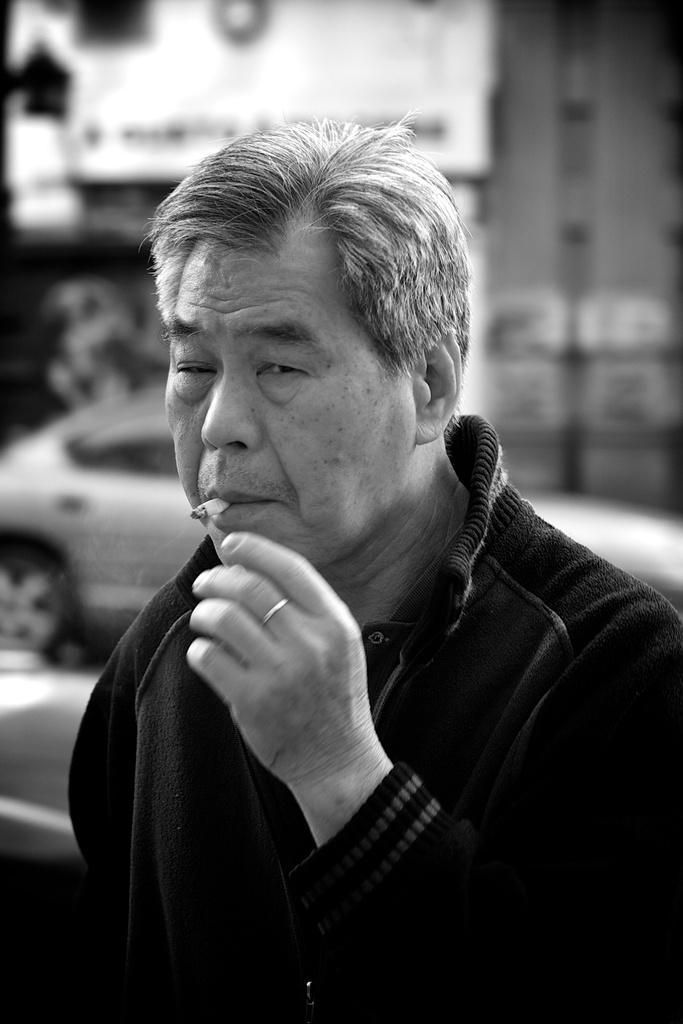How would you summarize this image in a sentence or two? There is a person in jacket having a cigarette in his mouth and smoking. In the background, there is a vehicle. And the background is blurred. 